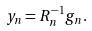Convert formula to latex. <formula><loc_0><loc_0><loc_500><loc_500>y _ { n } = R _ { n } ^ { - 1 } g _ { n } .</formula> 